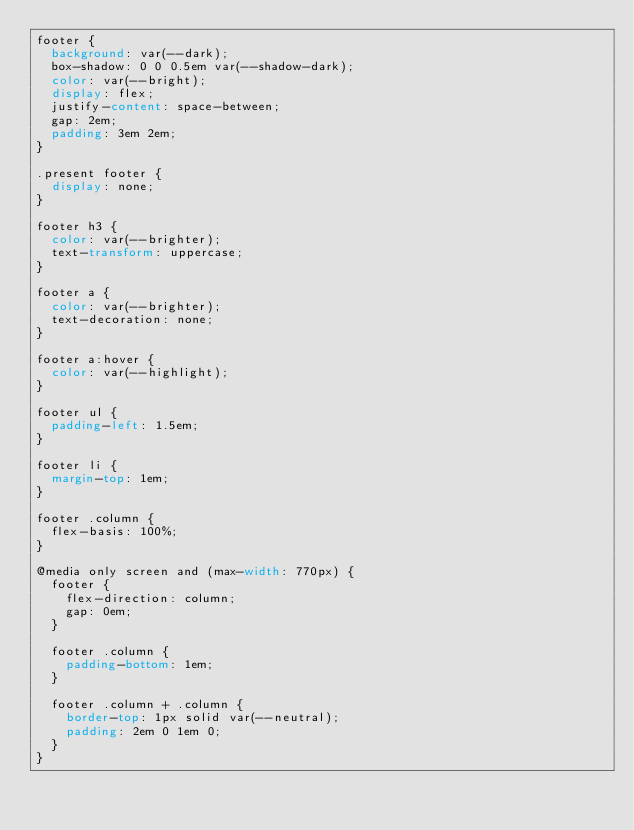<code> <loc_0><loc_0><loc_500><loc_500><_CSS_>footer {
  background: var(--dark);
  box-shadow: 0 0 0.5em var(--shadow-dark);
  color: var(--bright);
  display: flex;
  justify-content: space-between;
  gap: 2em;
  padding: 3em 2em;
}

.present footer {
  display: none;
}

footer h3 {
  color: var(--brighter);
  text-transform: uppercase;
}

footer a {
  color: var(--brighter);
  text-decoration: none;
}

footer a:hover {
  color: var(--highlight);
}

footer ul {
  padding-left: 1.5em;
}

footer li {
  margin-top: 1em;
}

footer .column {
  flex-basis: 100%;
}

@media only screen and (max-width: 770px) {
  footer {
    flex-direction: column;
    gap: 0em;
  }

  footer .column {
    padding-bottom: 1em;
  }

  footer .column + .column {
    border-top: 1px solid var(--neutral);
    padding: 2em 0 1em 0;
  }
}
</code> 